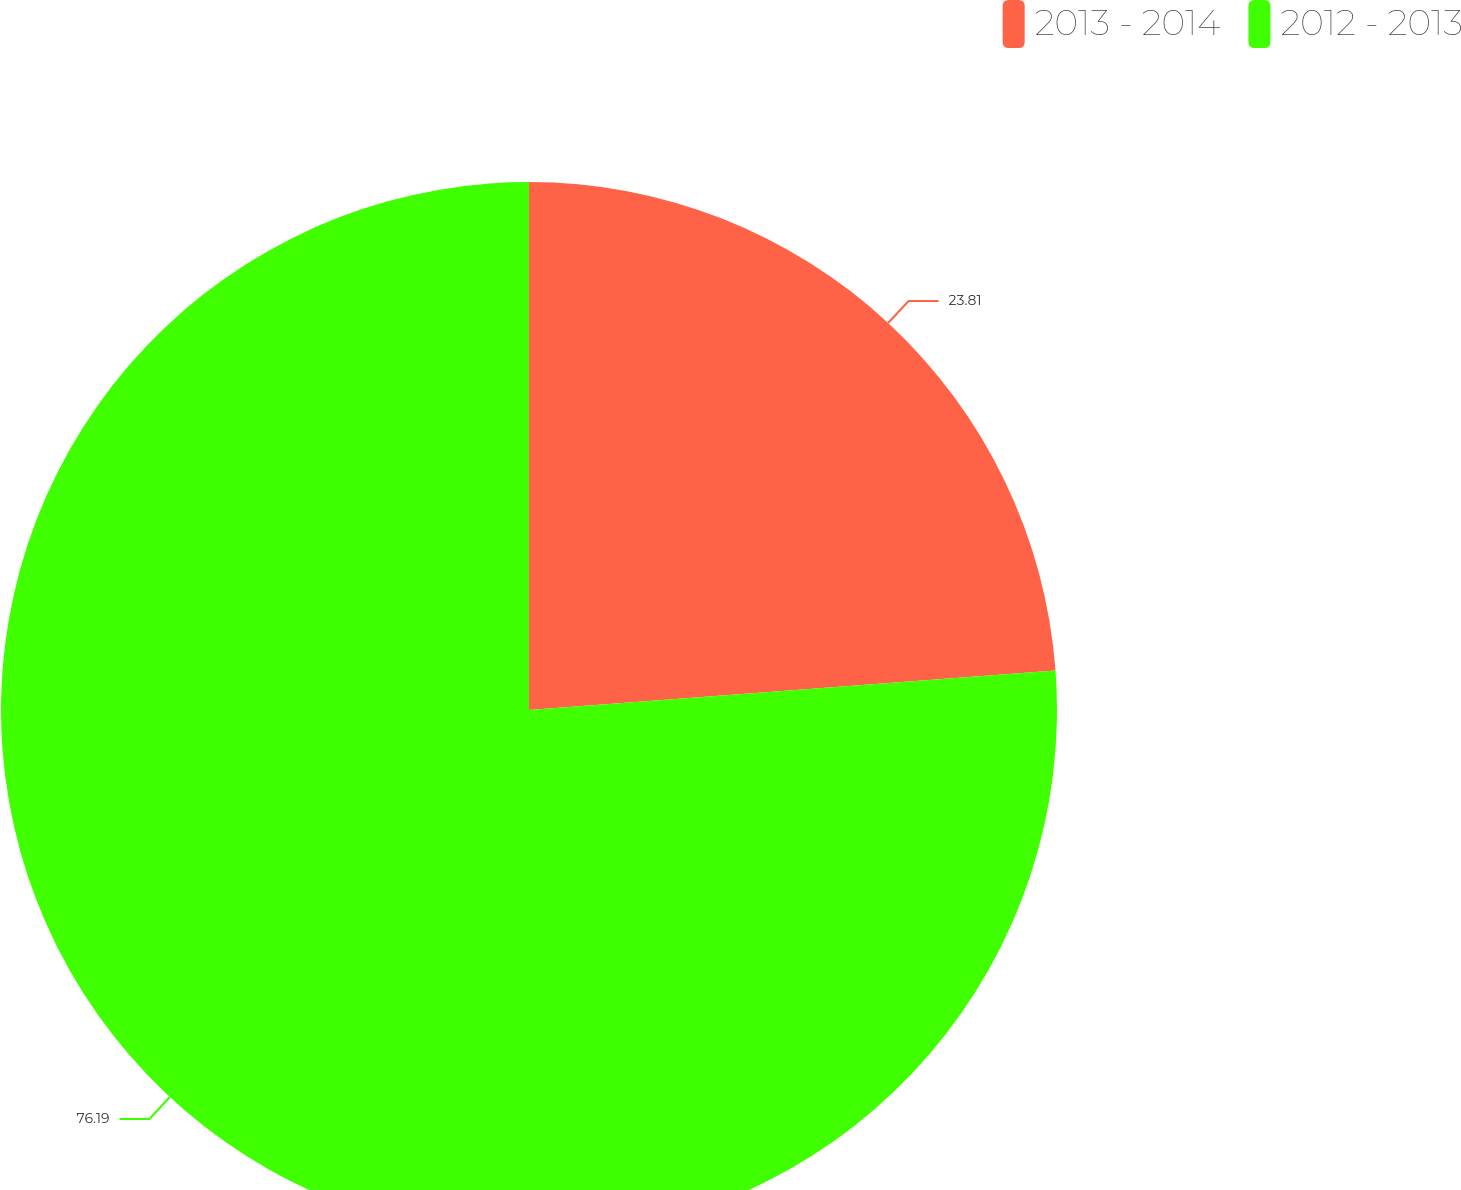<chart> <loc_0><loc_0><loc_500><loc_500><pie_chart><fcel>2013 - 2014<fcel>2012 - 2013<nl><fcel>23.81%<fcel>76.19%<nl></chart> 